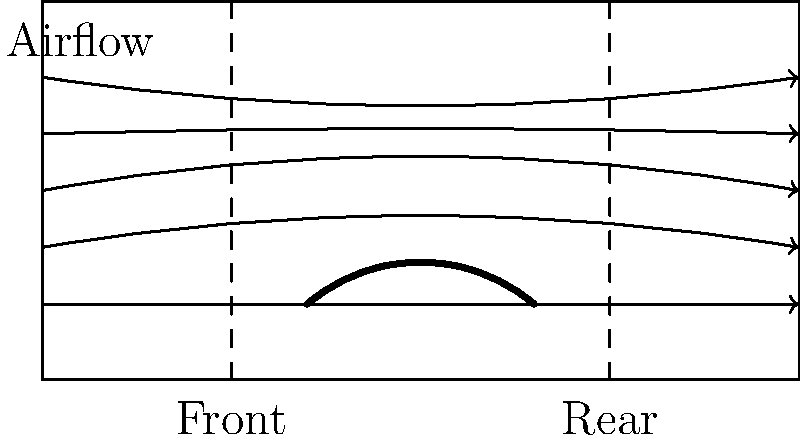Based on the wind tunnel diagram of Wayne Taylor Racing's DPi car, which aerodynamic principle is most likely responsible for the downforce generated by the car's body shape? To answer this question, let's analyze the wind tunnel diagram step-by-step:

1. The diagram shows the side profile of Wayne Taylor Racing's DPi car in a wind tunnel.

2. We can see airflow lines moving from left to right, representing the air passing over the car at high speeds.

3. The car's body shape is curved, with a higher profile at the center and lower profiles at the front and rear.

4. Observe that the airflow lines are not parallel to the ground. They curve upward as they pass over the car's body and then curve downward behind the car.

5. This curvature of the airflow is due to the car's body shape, which creates a difference in air pressure above and below the car.

6. The principle at work here is Bernoulli's principle, which states that an increase in the speed of a fluid occurs simultaneously with a decrease in pressure or a decrease in the fluid's potential energy.

7. As the air moves faster over the curved top of the car (due to the longer path it must travel compared to the air underneath), it creates an area of lower pressure above the car.

8. The higher pressure underneath the car combined with the lower pressure above creates a net upward force on the air.

9. According to Newton's Third Law, for every action, there is an equal and opposite reaction. Therefore, as the car pushes the air upward, the air pushes the car downward with equal force.

This downward force is what we call aerodynamic downforce, which helps improve the car's traction and cornering ability at high speeds.
Answer: Bernoulli's principle 